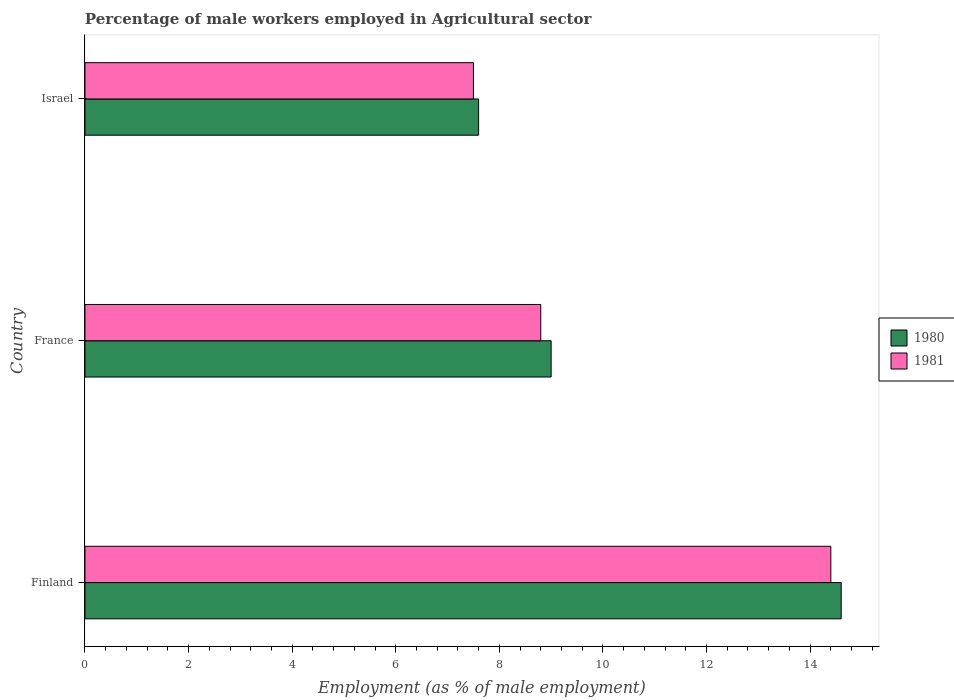How many different coloured bars are there?
Ensure brevity in your answer.  2. How many groups of bars are there?
Your answer should be compact. 3. Are the number of bars on each tick of the Y-axis equal?
Provide a succinct answer. Yes. What is the label of the 2nd group of bars from the top?
Offer a very short reply. France. What is the percentage of male workers employed in Agricultural sector in 1980 in Finland?
Provide a short and direct response. 14.6. Across all countries, what is the maximum percentage of male workers employed in Agricultural sector in 1981?
Your response must be concise. 14.4. Across all countries, what is the minimum percentage of male workers employed in Agricultural sector in 1980?
Keep it short and to the point. 7.6. In which country was the percentage of male workers employed in Agricultural sector in 1980 maximum?
Offer a very short reply. Finland. What is the total percentage of male workers employed in Agricultural sector in 1980 in the graph?
Make the answer very short. 31.2. What is the difference between the percentage of male workers employed in Agricultural sector in 1981 in France and that in Israel?
Offer a very short reply. 1.3. What is the difference between the percentage of male workers employed in Agricultural sector in 1981 in Israel and the percentage of male workers employed in Agricultural sector in 1980 in France?
Give a very brief answer. -1.5. What is the average percentage of male workers employed in Agricultural sector in 1980 per country?
Your response must be concise. 10.4. What is the difference between the percentage of male workers employed in Agricultural sector in 1980 and percentage of male workers employed in Agricultural sector in 1981 in Israel?
Give a very brief answer. 0.1. In how many countries, is the percentage of male workers employed in Agricultural sector in 1980 greater than 3.2 %?
Keep it short and to the point. 3. What is the ratio of the percentage of male workers employed in Agricultural sector in 1981 in Finland to that in France?
Provide a short and direct response. 1.64. What is the difference between the highest and the second highest percentage of male workers employed in Agricultural sector in 1981?
Your answer should be compact. 5.6. What is the difference between the highest and the lowest percentage of male workers employed in Agricultural sector in 1981?
Provide a short and direct response. 6.9. In how many countries, is the percentage of male workers employed in Agricultural sector in 1980 greater than the average percentage of male workers employed in Agricultural sector in 1980 taken over all countries?
Your response must be concise. 1. Is the sum of the percentage of male workers employed in Agricultural sector in 1980 in Finland and France greater than the maximum percentage of male workers employed in Agricultural sector in 1981 across all countries?
Provide a succinct answer. Yes. What does the 2nd bar from the top in Israel represents?
Provide a short and direct response. 1980. What does the 1st bar from the bottom in France represents?
Offer a very short reply. 1980. How many bars are there?
Your response must be concise. 6. Are all the bars in the graph horizontal?
Offer a terse response. Yes. How many countries are there in the graph?
Ensure brevity in your answer.  3. What is the difference between two consecutive major ticks on the X-axis?
Provide a short and direct response. 2. Are the values on the major ticks of X-axis written in scientific E-notation?
Your answer should be compact. No. Does the graph contain any zero values?
Your answer should be very brief. No. Does the graph contain grids?
Ensure brevity in your answer.  No. Where does the legend appear in the graph?
Your answer should be compact. Center right. How many legend labels are there?
Provide a succinct answer. 2. How are the legend labels stacked?
Your answer should be very brief. Vertical. What is the title of the graph?
Provide a short and direct response. Percentage of male workers employed in Agricultural sector. Does "1978" appear as one of the legend labels in the graph?
Provide a short and direct response. No. What is the label or title of the X-axis?
Make the answer very short. Employment (as % of male employment). What is the Employment (as % of male employment) of 1980 in Finland?
Provide a succinct answer. 14.6. What is the Employment (as % of male employment) in 1981 in Finland?
Provide a succinct answer. 14.4. What is the Employment (as % of male employment) in 1981 in France?
Provide a succinct answer. 8.8. What is the Employment (as % of male employment) of 1980 in Israel?
Keep it short and to the point. 7.6. Across all countries, what is the maximum Employment (as % of male employment) in 1980?
Offer a terse response. 14.6. Across all countries, what is the maximum Employment (as % of male employment) in 1981?
Your response must be concise. 14.4. Across all countries, what is the minimum Employment (as % of male employment) of 1980?
Provide a succinct answer. 7.6. Across all countries, what is the minimum Employment (as % of male employment) in 1981?
Your response must be concise. 7.5. What is the total Employment (as % of male employment) of 1980 in the graph?
Provide a succinct answer. 31.2. What is the total Employment (as % of male employment) in 1981 in the graph?
Your answer should be very brief. 30.7. What is the difference between the Employment (as % of male employment) in 1980 in Finland and that in Israel?
Provide a short and direct response. 7. What is the difference between the Employment (as % of male employment) of 1980 in Finland and the Employment (as % of male employment) of 1981 in France?
Give a very brief answer. 5.8. What is the difference between the Employment (as % of male employment) in 1980 in Finland and the Employment (as % of male employment) in 1981 in Israel?
Provide a succinct answer. 7.1. What is the average Employment (as % of male employment) of 1981 per country?
Your response must be concise. 10.23. What is the ratio of the Employment (as % of male employment) of 1980 in Finland to that in France?
Keep it short and to the point. 1.62. What is the ratio of the Employment (as % of male employment) of 1981 in Finland to that in France?
Make the answer very short. 1.64. What is the ratio of the Employment (as % of male employment) in 1980 in Finland to that in Israel?
Ensure brevity in your answer.  1.92. What is the ratio of the Employment (as % of male employment) of 1981 in Finland to that in Israel?
Give a very brief answer. 1.92. What is the ratio of the Employment (as % of male employment) in 1980 in France to that in Israel?
Your answer should be compact. 1.18. What is the ratio of the Employment (as % of male employment) in 1981 in France to that in Israel?
Make the answer very short. 1.17. What is the difference between the highest and the lowest Employment (as % of male employment) in 1980?
Offer a very short reply. 7. 